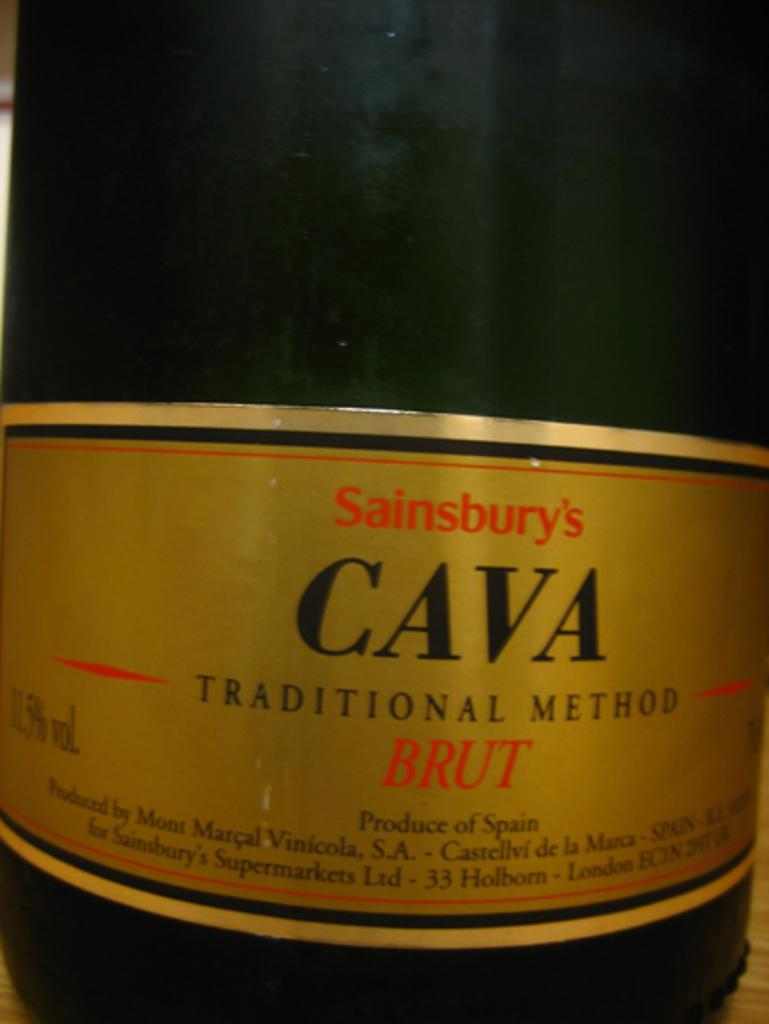<image>
Present a compact description of the photo's key features. A bottle of brut has a CAVA logo. 